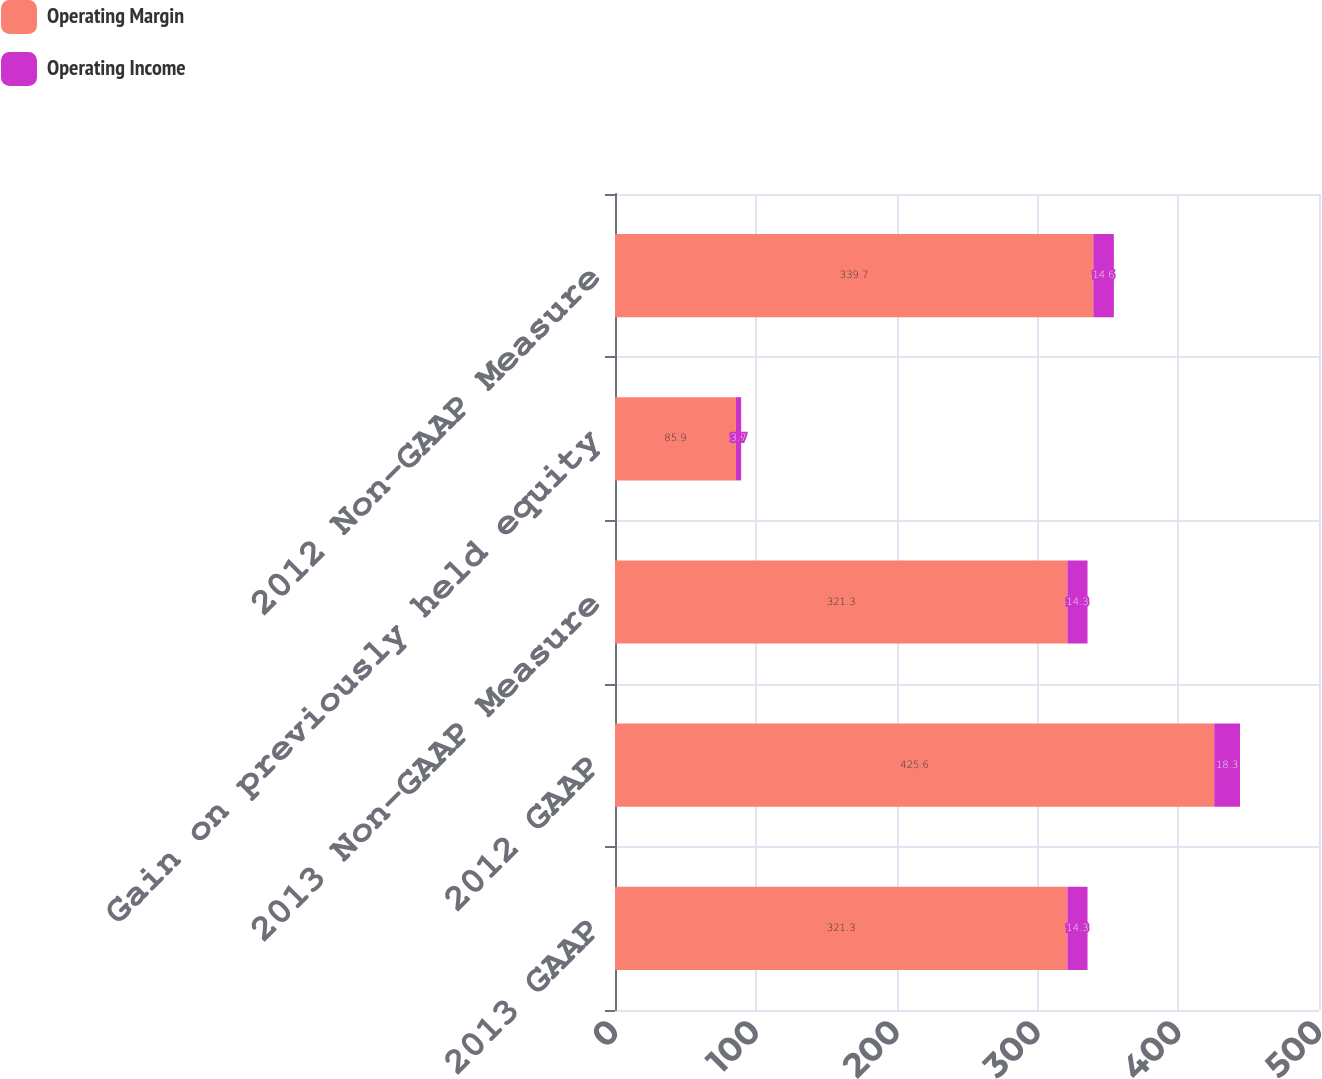<chart> <loc_0><loc_0><loc_500><loc_500><stacked_bar_chart><ecel><fcel>2013 GAAP<fcel>2012 GAAP<fcel>2013 Non-GAAP Measure<fcel>Gain on previously held equity<fcel>2012 Non-GAAP Measure<nl><fcel>Operating Margin<fcel>321.3<fcel>425.6<fcel>321.3<fcel>85.9<fcel>339.7<nl><fcel>Operating Income<fcel>14.3<fcel>18.3<fcel>14.3<fcel>3.7<fcel>14.6<nl></chart> 